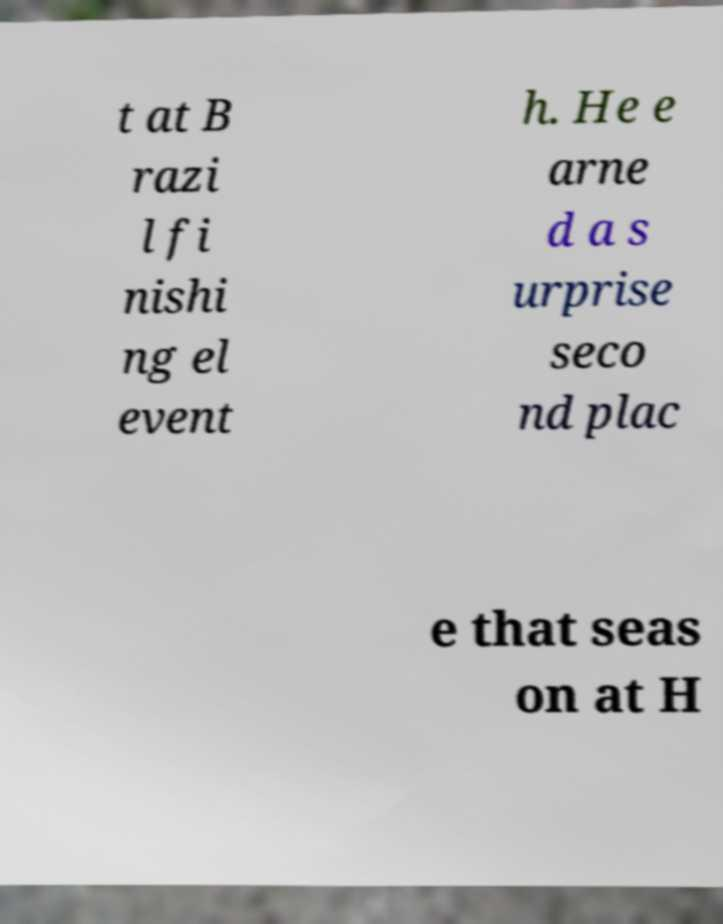Please identify and transcribe the text found in this image. t at B razi l fi nishi ng el event h. He e arne d a s urprise seco nd plac e that seas on at H 